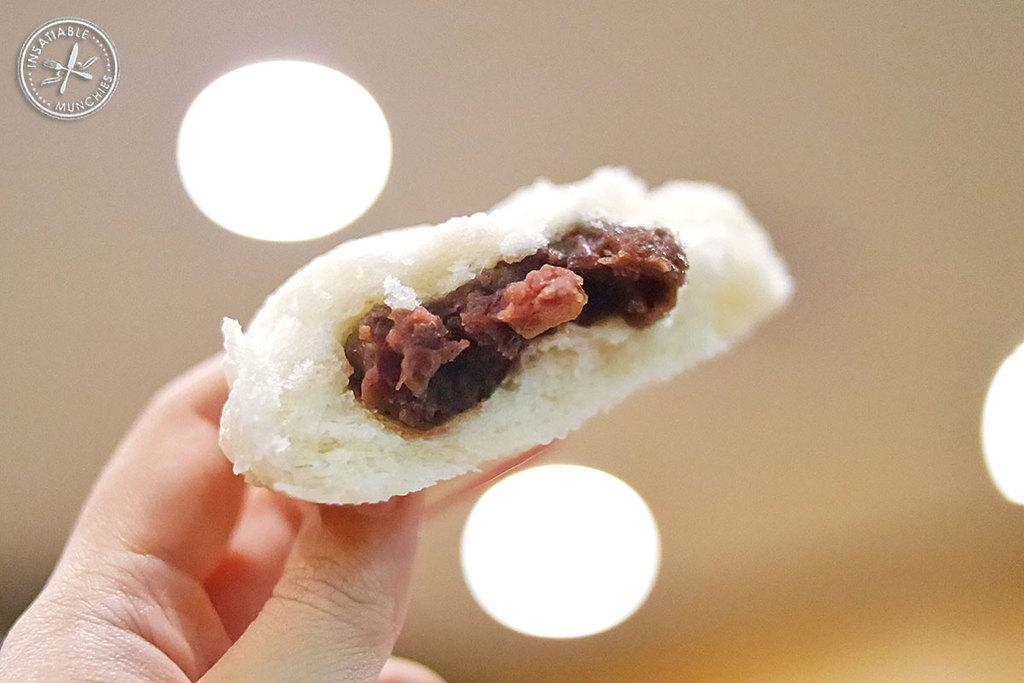What is the human hand holding in the image? There is a human hand holding a food item in the image. What else can be seen in the image besides the hand and food item? There are lights visible in the image. Is there any text or symbol in the image? Yes, there is a logo in the top left corner of the image. How would you describe the background of the image? The background of the image is blurry. What type of force is being applied by the hand on the food item in the image? There is no indication of force being applied by the hand on the food item in the image; it simply holds the food item. 